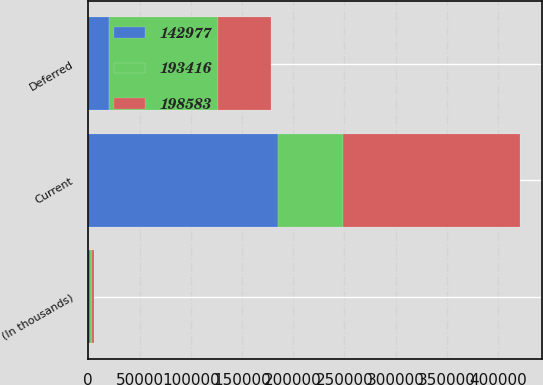Convert chart to OTSL. <chart><loc_0><loc_0><loc_500><loc_500><stacked_bar_chart><ecel><fcel>(In thousands)<fcel>Current<fcel>Deferred<nl><fcel>198583<fcel>2013<fcel>173418<fcel>51475<nl><fcel>142977<fcel>2012<fcel>185404<fcel>20086<nl><fcel>193416<fcel>2011<fcel>62810<fcel>106902<nl></chart> 